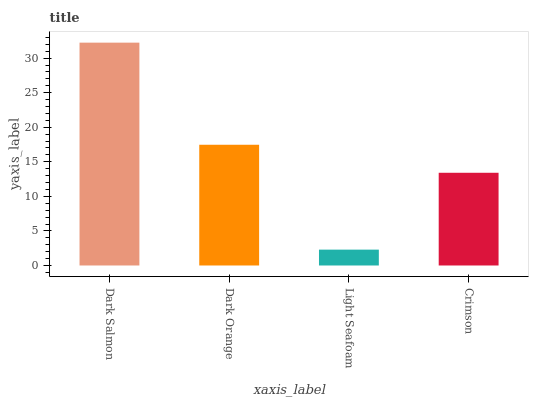Is Light Seafoam the minimum?
Answer yes or no. Yes. Is Dark Salmon the maximum?
Answer yes or no. Yes. Is Dark Orange the minimum?
Answer yes or no. No. Is Dark Orange the maximum?
Answer yes or no. No. Is Dark Salmon greater than Dark Orange?
Answer yes or no. Yes. Is Dark Orange less than Dark Salmon?
Answer yes or no. Yes. Is Dark Orange greater than Dark Salmon?
Answer yes or no. No. Is Dark Salmon less than Dark Orange?
Answer yes or no. No. Is Dark Orange the high median?
Answer yes or no. Yes. Is Crimson the low median?
Answer yes or no. Yes. Is Crimson the high median?
Answer yes or no. No. Is Dark Orange the low median?
Answer yes or no. No. 